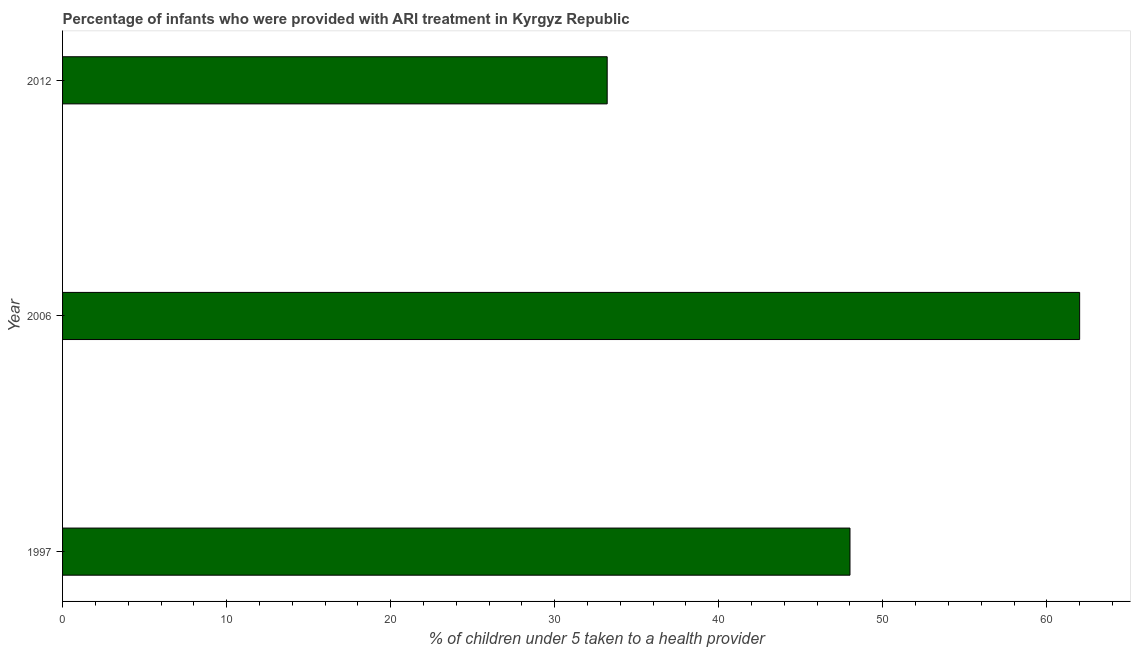Does the graph contain any zero values?
Ensure brevity in your answer.  No. What is the title of the graph?
Your response must be concise. Percentage of infants who were provided with ARI treatment in Kyrgyz Republic. What is the label or title of the X-axis?
Make the answer very short. % of children under 5 taken to a health provider. What is the label or title of the Y-axis?
Provide a succinct answer. Year. What is the percentage of children who were provided with ari treatment in 2012?
Provide a succinct answer. 33.2. Across all years, what is the maximum percentage of children who were provided with ari treatment?
Make the answer very short. 62. Across all years, what is the minimum percentage of children who were provided with ari treatment?
Provide a short and direct response. 33.2. What is the sum of the percentage of children who were provided with ari treatment?
Ensure brevity in your answer.  143.2. What is the difference between the percentage of children who were provided with ari treatment in 1997 and 2012?
Keep it short and to the point. 14.8. What is the average percentage of children who were provided with ari treatment per year?
Provide a short and direct response. 47.73. What is the median percentage of children who were provided with ari treatment?
Your answer should be compact. 48. Do a majority of the years between 2006 and 2012 (inclusive) have percentage of children who were provided with ari treatment greater than 56 %?
Make the answer very short. No. What is the ratio of the percentage of children who were provided with ari treatment in 1997 to that in 2006?
Offer a terse response. 0.77. Is the difference between the percentage of children who were provided with ari treatment in 1997 and 2012 greater than the difference between any two years?
Ensure brevity in your answer.  No. What is the difference between the highest and the second highest percentage of children who were provided with ari treatment?
Give a very brief answer. 14. What is the difference between the highest and the lowest percentage of children who were provided with ari treatment?
Provide a short and direct response. 28.8. How many years are there in the graph?
Ensure brevity in your answer.  3. What is the % of children under 5 taken to a health provider in 2006?
Provide a succinct answer. 62. What is the % of children under 5 taken to a health provider of 2012?
Your answer should be very brief. 33.2. What is the difference between the % of children under 5 taken to a health provider in 2006 and 2012?
Give a very brief answer. 28.8. What is the ratio of the % of children under 5 taken to a health provider in 1997 to that in 2006?
Offer a terse response. 0.77. What is the ratio of the % of children under 5 taken to a health provider in 1997 to that in 2012?
Your answer should be compact. 1.45. What is the ratio of the % of children under 5 taken to a health provider in 2006 to that in 2012?
Give a very brief answer. 1.87. 